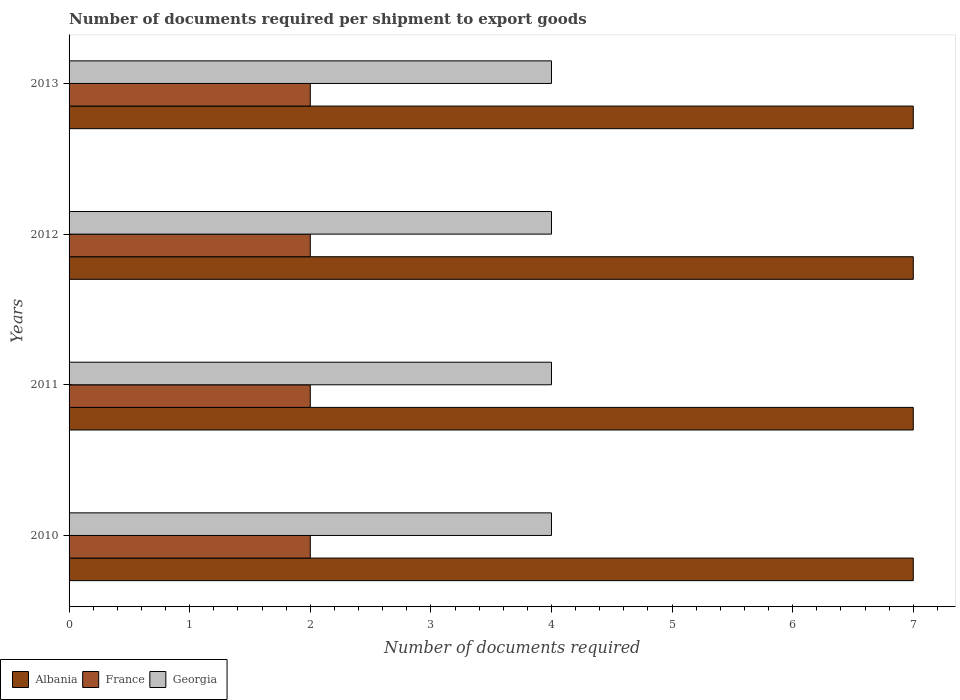How many different coloured bars are there?
Ensure brevity in your answer.  3. How many groups of bars are there?
Offer a terse response. 4. Are the number of bars per tick equal to the number of legend labels?
Keep it short and to the point. Yes. Are the number of bars on each tick of the Y-axis equal?
Keep it short and to the point. Yes. How many bars are there on the 2nd tick from the top?
Ensure brevity in your answer.  3. What is the label of the 2nd group of bars from the top?
Your response must be concise. 2012. What is the number of documents required per shipment to export goods in Albania in 2010?
Provide a succinct answer. 7. Across all years, what is the maximum number of documents required per shipment to export goods in Georgia?
Give a very brief answer. 4. Across all years, what is the minimum number of documents required per shipment to export goods in Albania?
Offer a terse response. 7. In which year was the number of documents required per shipment to export goods in Albania maximum?
Your answer should be very brief. 2010. What is the total number of documents required per shipment to export goods in Albania in the graph?
Keep it short and to the point. 28. What is the difference between the number of documents required per shipment to export goods in Georgia in 2010 and that in 2013?
Provide a succinct answer. 0. What is the difference between the number of documents required per shipment to export goods in France in 2013 and the number of documents required per shipment to export goods in Albania in 2012?
Offer a terse response. -5. What is the average number of documents required per shipment to export goods in France per year?
Offer a very short reply. 2. In the year 2011, what is the difference between the number of documents required per shipment to export goods in France and number of documents required per shipment to export goods in Georgia?
Provide a short and direct response. -2. In how many years, is the number of documents required per shipment to export goods in France greater than 4.6 ?
Your answer should be compact. 0. What is the ratio of the number of documents required per shipment to export goods in Georgia in 2012 to that in 2013?
Keep it short and to the point. 1. Is the number of documents required per shipment to export goods in Georgia in 2011 less than that in 2013?
Make the answer very short. No. Is the difference between the number of documents required per shipment to export goods in France in 2010 and 2011 greater than the difference between the number of documents required per shipment to export goods in Georgia in 2010 and 2011?
Your answer should be very brief. No. What is the difference between the highest and the lowest number of documents required per shipment to export goods in Albania?
Your answer should be very brief. 0. What does the 1st bar from the top in 2012 represents?
Offer a terse response. Georgia. What does the 1st bar from the bottom in 2013 represents?
Keep it short and to the point. Albania. Is it the case that in every year, the sum of the number of documents required per shipment to export goods in France and number of documents required per shipment to export goods in Georgia is greater than the number of documents required per shipment to export goods in Albania?
Ensure brevity in your answer.  No. How many bars are there?
Keep it short and to the point. 12. Are all the bars in the graph horizontal?
Offer a very short reply. Yes. How many years are there in the graph?
Offer a very short reply. 4. Are the values on the major ticks of X-axis written in scientific E-notation?
Your answer should be compact. No. Where does the legend appear in the graph?
Ensure brevity in your answer.  Bottom left. How many legend labels are there?
Provide a succinct answer. 3. How are the legend labels stacked?
Your answer should be very brief. Horizontal. What is the title of the graph?
Provide a succinct answer. Number of documents required per shipment to export goods. Does "Philippines" appear as one of the legend labels in the graph?
Provide a succinct answer. No. What is the label or title of the X-axis?
Your answer should be very brief. Number of documents required. What is the label or title of the Y-axis?
Your answer should be very brief. Years. What is the Number of documents required in Albania in 2010?
Provide a short and direct response. 7. What is the Number of documents required in Albania in 2011?
Offer a very short reply. 7. What is the Number of documents required of France in 2011?
Provide a succinct answer. 2. What is the Number of documents required in Georgia in 2011?
Give a very brief answer. 4. What is the Number of documents required of Albania in 2013?
Provide a succinct answer. 7. What is the Number of documents required of France in 2013?
Offer a very short reply. 2. What is the Number of documents required in Georgia in 2013?
Provide a succinct answer. 4. Across all years, what is the maximum Number of documents required in Georgia?
Make the answer very short. 4. Across all years, what is the minimum Number of documents required of Albania?
Your answer should be very brief. 7. Across all years, what is the minimum Number of documents required of Georgia?
Provide a short and direct response. 4. What is the total Number of documents required of Albania in the graph?
Give a very brief answer. 28. What is the total Number of documents required of France in the graph?
Ensure brevity in your answer.  8. What is the difference between the Number of documents required in Albania in 2010 and that in 2011?
Your response must be concise. 0. What is the difference between the Number of documents required in France in 2010 and that in 2011?
Give a very brief answer. 0. What is the difference between the Number of documents required of Albania in 2010 and that in 2012?
Your response must be concise. 0. What is the difference between the Number of documents required in Albania in 2010 and that in 2013?
Your answer should be very brief. 0. What is the difference between the Number of documents required in Albania in 2011 and that in 2012?
Your response must be concise. 0. What is the difference between the Number of documents required in France in 2011 and that in 2012?
Provide a short and direct response. 0. What is the difference between the Number of documents required of Georgia in 2011 and that in 2012?
Offer a very short reply. 0. What is the difference between the Number of documents required in Albania in 2011 and that in 2013?
Offer a terse response. 0. What is the difference between the Number of documents required in Albania in 2012 and that in 2013?
Your response must be concise. 0. What is the difference between the Number of documents required of France in 2012 and that in 2013?
Provide a succinct answer. 0. What is the difference between the Number of documents required of Albania in 2010 and the Number of documents required of France in 2011?
Make the answer very short. 5. What is the difference between the Number of documents required of Albania in 2010 and the Number of documents required of France in 2012?
Offer a terse response. 5. What is the difference between the Number of documents required of Albania in 2010 and the Number of documents required of Georgia in 2012?
Your response must be concise. 3. What is the difference between the Number of documents required of France in 2010 and the Number of documents required of Georgia in 2013?
Make the answer very short. -2. What is the difference between the Number of documents required in Albania in 2011 and the Number of documents required in Georgia in 2012?
Your response must be concise. 3. What is the difference between the Number of documents required in France in 2011 and the Number of documents required in Georgia in 2012?
Ensure brevity in your answer.  -2. What is the difference between the Number of documents required of France in 2012 and the Number of documents required of Georgia in 2013?
Your response must be concise. -2. What is the average Number of documents required of Albania per year?
Provide a succinct answer. 7. In the year 2010, what is the difference between the Number of documents required in Albania and Number of documents required in France?
Keep it short and to the point. 5. In the year 2011, what is the difference between the Number of documents required of France and Number of documents required of Georgia?
Provide a short and direct response. -2. In the year 2012, what is the difference between the Number of documents required of Albania and Number of documents required of Georgia?
Your answer should be very brief. 3. In the year 2013, what is the difference between the Number of documents required in Albania and Number of documents required in Georgia?
Give a very brief answer. 3. In the year 2013, what is the difference between the Number of documents required of France and Number of documents required of Georgia?
Provide a succinct answer. -2. What is the ratio of the Number of documents required in Albania in 2010 to that in 2011?
Keep it short and to the point. 1. What is the ratio of the Number of documents required of France in 2010 to that in 2011?
Provide a succinct answer. 1. What is the ratio of the Number of documents required in Georgia in 2010 to that in 2011?
Give a very brief answer. 1. What is the ratio of the Number of documents required in Albania in 2010 to that in 2012?
Offer a very short reply. 1. What is the ratio of the Number of documents required in Albania in 2010 to that in 2013?
Offer a very short reply. 1. What is the ratio of the Number of documents required in Albania in 2011 to that in 2012?
Ensure brevity in your answer.  1. What is the ratio of the Number of documents required of France in 2011 to that in 2012?
Provide a succinct answer. 1. What is the ratio of the Number of documents required in Georgia in 2011 to that in 2012?
Offer a very short reply. 1. What is the ratio of the Number of documents required in Albania in 2011 to that in 2013?
Offer a terse response. 1. What is the ratio of the Number of documents required of Albania in 2012 to that in 2013?
Offer a terse response. 1. What is the difference between the highest and the second highest Number of documents required of Albania?
Your answer should be compact. 0. 